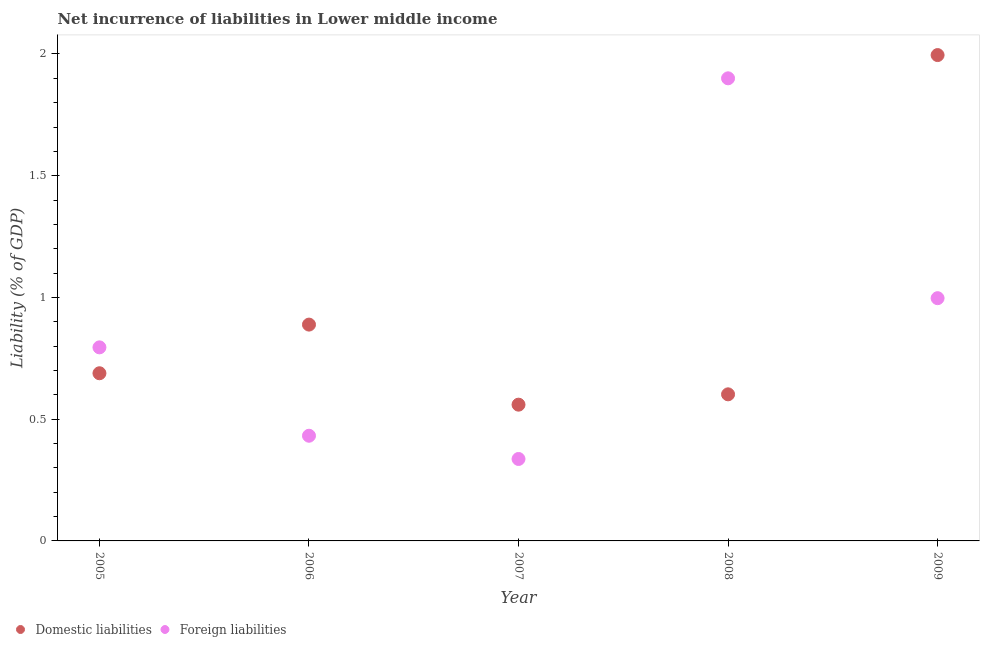How many different coloured dotlines are there?
Offer a terse response. 2. What is the incurrence of domestic liabilities in 2009?
Make the answer very short. 2. Across all years, what is the maximum incurrence of domestic liabilities?
Your answer should be very brief. 2. Across all years, what is the minimum incurrence of domestic liabilities?
Give a very brief answer. 0.56. In which year was the incurrence of domestic liabilities maximum?
Give a very brief answer. 2009. In which year was the incurrence of domestic liabilities minimum?
Your answer should be very brief. 2007. What is the total incurrence of domestic liabilities in the graph?
Your answer should be compact. 4.73. What is the difference between the incurrence of foreign liabilities in 2006 and that in 2009?
Keep it short and to the point. -0.57. What is the difference between the incurrence of domestic liabilities in 2007 and the incurrence of foreign liabilities in 2005?
Offer a very short reply. -0.24. What is the average incurrence of domestic liabilities per year?
Provide a short and direct response. 0.95. In the year 2006, what is the difference between the incurrence of foreign liabilities and incurrence of domestic liabilities?
Your answer should be very brief. -0.46. What is the ratio of the incurrence of foreign liabilities in 2006 to that in 2007?
Give a very brief answer. 1.28. Is the difference between the incurrence of foreign liabilities in 2006 and 2008 greater than the difference between the incurrence of domestic liabilities in 2006 and 2008?
Provide a succinct answer. No. What is the difference between the highest and the second highest incurrence of foreign liabilities?
Your answer should be compact. 0.9. What is the difference between the highest and the lowest incurrence of foreign liabilities?
Offer a very short reply. 1.56. Does the incurrence of foreign liabilities monotonically increase over the years?
Your answer should be very brief. No. Is the incurrence of domestic liabilities strictly greater than the incurrence of foreign liabilities over the years?
Offer a very short reply. No. Does the graph contain grids?
Offer a very short reply. No. How many legend labels are there?
Your answer should be compact. 2. How are the legend labels stacked?
Offer a very short reply. Horizontal. What is the title of the graph?
Your response must be concise. Net incurrence of liabilities in Lower middle income. What is the label or title of the Y-axis?
Keep it short and to the point. Liability (% of GDP). What is the Liability (% of GDP) of Domestic liabilities in 2005?
Your answer should be very brief. 0.69. What is the Liability (% of GDP) in Foreign liabilities in 2005?
Your answer should be compact. 0.8. What is the Liability (% of GDP) of Domestic liabilities in 2006?
Provide a succinct answer. 0.89. What is the Liability (% of GDP) of Foreign liabilities in 2006?
Your response must be concise. 0.43. What is the Liability (% of GDP) in Domestic liabilities in 2007?
Ensure brevity in your answer.  0.56. What is the Liability (% of GDP) of Foreign liabilities in 2007?
Your answer should be very brief. 0.34. What is the Liability (% of GDP) in Domestic liabilities in 2008?
Ensure brevity in your answer.  0.6. What is the Liability (% of GDP) of Foreign liabilities in 2008?
Keep it short and to the point. 1.9. What is the Liability (% of GDP) of Domestic liabilities in 2009?
Provide a short and direct response. 2. What is the Liability (% of GDP) of Foreign liabilities in 2009?
Keep it short and to the point. 1. Across all years, what is the maximum Liability (% of GDP) in Domestic liabilities?
Make the answer very short. 2. Across all years, what is the maximum Liability (% of GDP) in Foreign liabilities?
Your answer should be very brief. 1.9. Across all years, what is the minimum Liability (% of GDP) in Domestic liabilities?
Ensure brevity in your answer.  0.56. Across all years, what is the minimum Liability (% of GDP) of Foreign liabilities?
Offer a very short reply. 0.34. What is the total Liability (% of GDP) in Domestic liabilities in the graph?
Offer a terse response. 4.73. What is the total Liability (% of GDP) of Foreign liabilities in the graph?
Provide a short and direct response. 4.46. What is the difference between the Liability (% of GDP) of Domestic liabilities in 2005 and that in 2006?
Keep it short and to the point. -0.2. What is the difference between the Liability (% of GDP) in Foreign liabilities in 2005 and that in 2006?
Keep it short and to the point. 0.36. What is the difference between the Liability (% of GDP) of Domestic liabilities in 2005 and that in 2007?
Offer a very short reply. 0.13. What is the difference between the Liability (% of GDP) of Foreign liabilities in 2005 and that in 2007?
Make the answer very short. 0.46. What is the difference between the Liability (% of GDP) of Domestic liabilities in 2005 and that in 2008?
Provide a succinct answer. 0.09. What is the difference between the Liability (% of GDP) of Foreign liabilities in 2005 and that in 2008?
Make the answer very short. -1.1. What is the difference between the Liability (% of GDP) of Domestic liabilities in 2005 and that in 2009?
Offer a very short reply. -1.31. What is the difference between the Liability (% of GDP) in Foreign liabilities in 2005 and that in 2009?
Provide a succinct answer. -0.2. What is the difference between the Liability (% of GDP) of Domestic liabilities in 2006 and that in 2007?
Offer a very short reply. 0.33. What is the difference between the Liability (% of GDP) in Foreign liabilities in 2006 and that in 2007?
Offer a very short reply. 0.1. What is the difference between the Liability (% of GDP) of Domestic liabilities in 2006 and that in 2008?
Offer a very short reply. 0.29. What is the difference between the Liability (% of GDP) in Foreign liabilities in 2006 and that in 2008?
Your answer should be very brief. -1.47. What is the difference between the Liability (% of GDP) in Domestic liabilities in 2006 and that in 2009?
Your answer should be very brief. -1.11. What is the difference between the Liability (% of GDP) of Foreign liabilities in 2006 and that in 2009?
Provide a succinct answer. -0.56. What is the difference between the Liability (% of GDP) in Domestic liabilities in 2007 and that in 2008?
Provide a succinct answer. -0.04. What is the difference between the Liability (% of GDP) in Foreign liabilities in 2007 and that in 2008?
Provide a short and direct response. -1.56. What is the difference between the Liability (% of GDP) in Domestic liabilities in 2007 and that in 2009?
Offer a terse response. -1.44. What is the difference between the Liability (% of GDP) in Foreign liabilities in 2007 and that in 2009?
Your answer should be very brief. -0.66. What is the difference between the Liability (% of GDP) in Domestic liabilities in 2008 and that in 2009?
Ensure brevity in your answer.  -1.39. What is the difference between the Liability (% of GDP) in Foreign liabilities in 2008 and that in 2009?
Your answer should be compact. 0.9. What is the difference between the Liability (% of GDP) in Domestic liabilities in 2005 and the Liability (% of GDP) in Foreign liabilities in 2006?
Provide a short and direct response. 0.26. What is the difference between the Liability (% of GDP) of Domestic liabilities in 2005 and the Liability (% of GDP) of Foreign liabilities in 2007?
Your answer should be very brief. 0.35. What is the difference between the Liability (% of GDP) of Domestic liabilities in 2005 and the Liability (% of GDP) of Foreign liabilities in 2008?
Ensure brevity in your answer.  -1.21. What is the difference between the Liability (% of GDP) in Domestic liabilities in 2005 and the Liability (% of GDP) in Foreign liabilities in 2009?
Ensure brevity in your answer.  -0.31. What is the difference between the Liability (% of GDP) in Domestic liabilities in 2006 and the Liability (% of GDP) in Foreign liabilities in 2007?
Make the answer very short. 0.55. What is the difference between the Liability (% of GDP) of Domestic liabilities in 2006 and the Liability (% of GDP) of Foreign liabilities in 2008?
Your response must be concise. -1.01. What is the difference between the Liability (% of GDP) of Domestic liabilities in 2006 and the Liability (% of GDP) of Foreign liabilities in 2009?
Make the answer very short. -0.11. What is the difference between the Liability (% of GDP) of Domestic liabilities in 2007 and the Liability (% of GDP) of Foreign liabilities in 2008?
Make the answer very short. -1.34. What is the difference between the Liability (% of GDP) in Domestic liabilities in 2007 and the Liability (% of GDP) in Foreign liabilities in 2009?
Give a very brief answer. -0.44. What is the difference between the Liability (% of GDP) in Domestic liabilities in 2008 and the Liability (% of GDP) in Foreign liabilities in 2009?
Provide a short and direct response. -0.39. What is the average Liability (% of GDP) of Domestic liabilities per year?
Offer a terse response. 0.95. What is the average Liability (% of GDP) in Foreign liabilities per year?
Keep it short and to the point. 0.89. In the year 2005, what is the difference between the Liability (% of GDP) in Domestic liabilities and Liability (% of GDP) in Foreign liabilities?
Ensure brevity in your answer.  -0.11. In the year 2006, what is the difference between the Liability (% of GDP) in Domestic liabilities and Liability (% of GDP) in Foreign liabilities?
Offer a very short reply. 0.46. In the year 2007, what is the difference between the Liability (% of GDP) in Domestic liabilities and Liability (% of GDP) in Foreign liabilities?
Offer a very short reply. 0.22. In the year 2008, what is the difference between the Liability (% of GDP) in Domestic liabilities and Liability (% of GDP) in Foreign liabilities?
Your answer should be compact. -1.3. In the year 2009, what is the difference between the Liability (% of GDP) of Domestic liabilities and Liability (% of GDP) of Foreign liabilities?
Provide a succinct answer. 1. What is the ratio of the Liability (% of GDP) of Domestic liabilities in 2005 to that in 2006?
Your answer should be compact. 0.78. What is the ratio of the Liability (% of GDP) of Foreign liabilities in 2005 to that in 2006?
Your response must be concise. 1.84. What is the ratio of the Liability (% of GDP) in Domestic liabilities in 2005 to that in 2007?
Make the answer very short. 1.23. What is the ratio of the Liability (% of GDP) of Foreign liabilities in 2005 to that in 2007?
Your answer should be compact. 2.36. What is the ratio of the Liability (% of GDP) in Domestic liabilities in 2005 to that in 2008?
Ensure brevity in your answer.  1.14. What is the ratio of the Liability (% of GDP) in Foreign liabilities in 2005 to that in 2008?
Your answer should be compact. 0.42. What is the ratio of the Liability (% of GDP) of Domestic liabilities in 2005 to that in 2009?
Your response must be concise. 0.35. What is the ratio of the Liability (% of GDP) in Foreign liabilities in 2005 to that in 2009?
Your answer should be compact. 0.8. What is the ratio of the Liability (% of GDP) of Domestic liabilities in 2006 to that in 2007?
Give a very brief answer. 1.59. What is the ratio of the Liability (% of GDP) in Foreign liabilities in 2006 to that in 2007?
Your answer should be very brief. 1.28. What is the ratio of the Liability (% of GDP) of Domestic liabilities in 2006 to that in 2008?
Offer a very short reply. 1.48. What is the ratio of the Liability (% of GDP) in Foreign liabilities in 2006 to that in 2008?
Offer a very short reply. 0.23. What is the ratio of the Liability (% of GDP) of Domestic liabilities in 2006 to that in 2009?
Ensure brevity in your answer.  0.45. What is the ratio of the Liability (% of GDP) of Foreign liabilities in 2006 to that in 2009?
Offer a very short reply. 0.43. What is the ratio of the Liability (% of GDP) in Domestic liabilities in 2007 to that in 2008?
Provide a succinct answer. 0.93. What is the ratio of the Liability (% of GDP) of Foreign liabilities in 2007 to that in 2008?
Make the answer very short. 0.18. What is the ratio of the Liability (% of GDP) in Domestic liabilities in 2007 to that in 2009?
Provide a succinct answer. 0.28. What is the ratio of the Liability (% of GDP) of Foreign liabilities in 2007 to that in 2009?
Ensure brevity in your answer.  0.34. What is the ratio of the Liability (% of GDP) in Domestic liabilities in 2008 to that in 2009?
Your response must be concise. 0.3. What is the ratio of the Liability (% of GDP) of Foreign liabilities in 2008 to that in 2009?
Your answer should be compact. 1.91. What is the difference between the highest and the second highest Liability (% of GDP) in Domestic liabilities?
Keep it short and to the point. 1.11. What is the difference between the highest and the second highest Liability (% of GDP) in Foreign liabilities?
Ensure brevity in your answer.  0.9. What is the difference between the highest and the lowest Liability (% of GDP) of Domestic liabilities?
Provide a succinct answer. 1.44. What is the difference between the highest and the lowest Liability (% of GDP) in Foreign liabilities?
Your answer should be very brief. 1.56. 